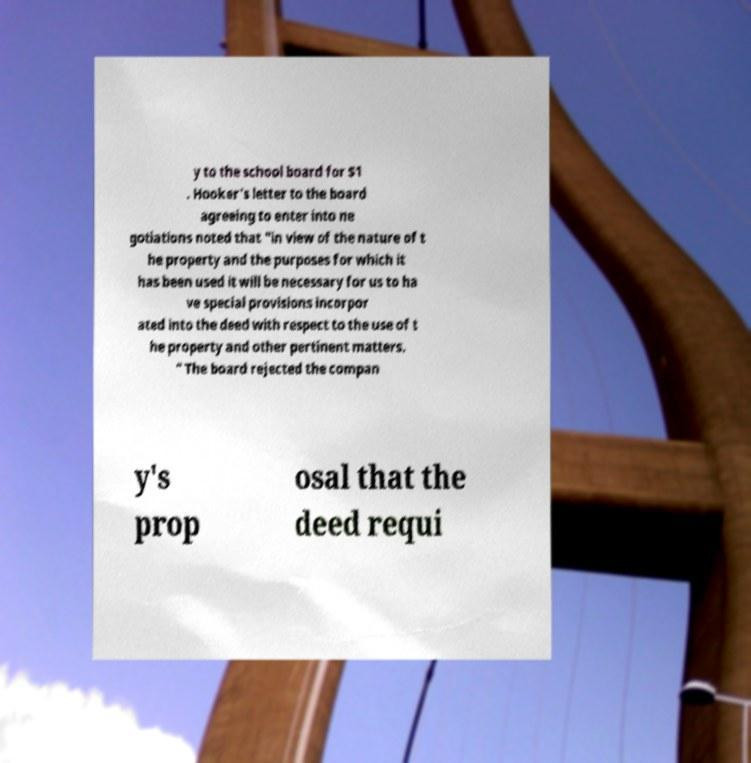Could you assist in decoding the text presented in this image and type it out clearly? y to the school board for $1 . Hooker's letter to the board agreeing to enter into ne gotiations noted that "in view of the nature of t he property and the purposes for which it has been used it will be necessary for us to ha ve special provisions incorpor ated into the deed with respect to the use of t he property and other pertinent matters. " The board rejected the compan y's prop osal that the deed requi 